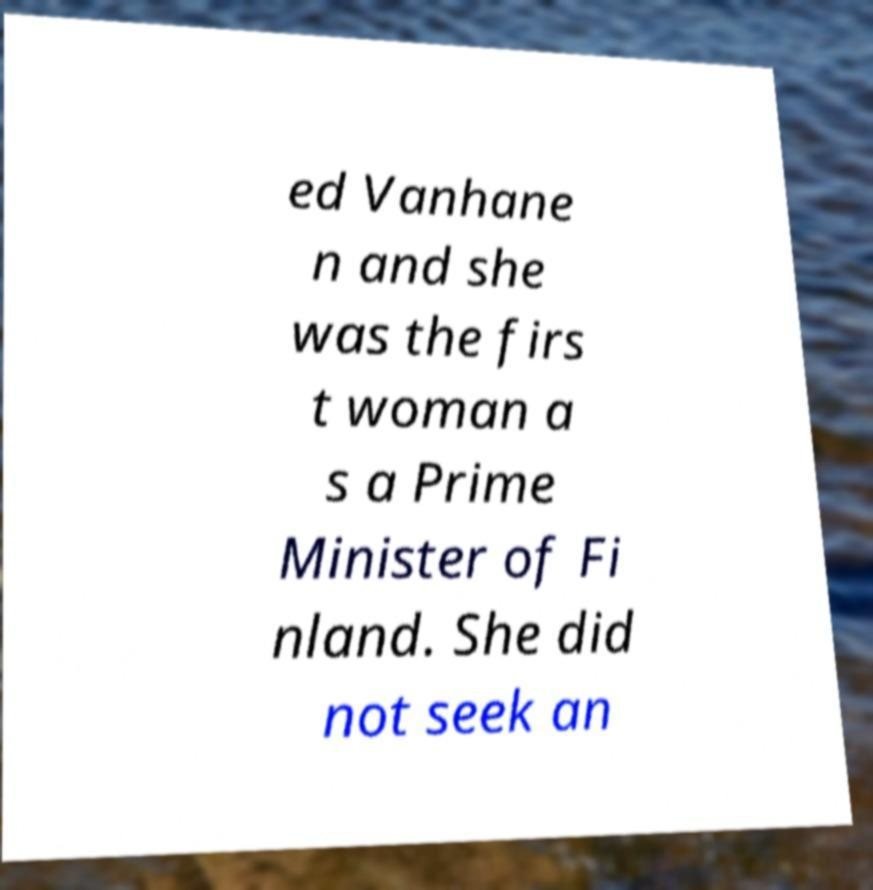What messages or text are displayed in this image? I need them in a readable, typed format. ed Vanhane n and she was the firs t woman a s a Prime Minister of Fi nland. She did not seek an 